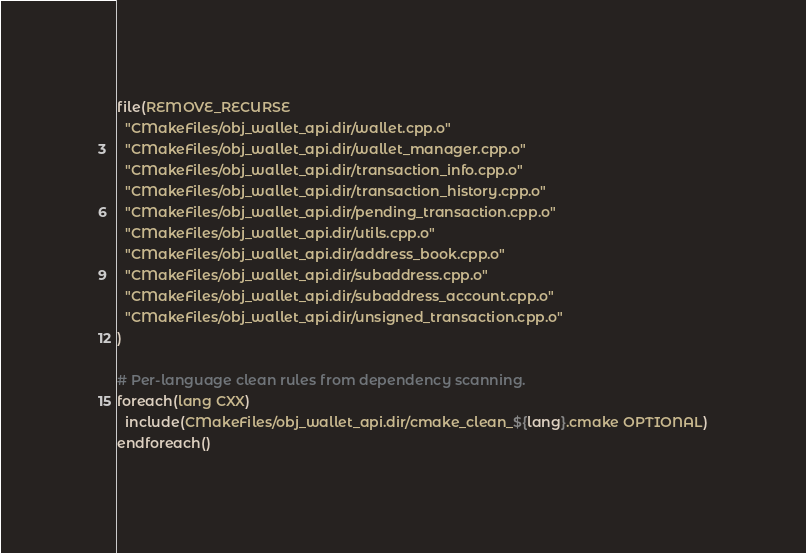Convert code to text. <code><loc_0><loc_0><loc_500><loc_500><_CMake_>file(REMOVE_RECURSE
  "CMakeFiles/obj_wallet_api.dir/wallet.cpp.o"
  "CMakeFiles/obj_wallet_api.dir/wallet_manager.cpp.o"
  "CMakeFiles/obj_wallet_api.dir/transaction_info.cpp.o"
  "CMakeFiles/obj_wallet_api.dir/transaction_history.cpp.o"
  "CMakeFiles/obj_wallet_api.dir/pending_transaction.cpp.o"
  "CMakeFiles/obj_wallet_api.dir/utils.cpp.o"
  "CMakeFiles/obj_wallet_api.dir/address_book.cpp.o"
  "CMakeFiles/obj_wallet_api.dir/subaddress.cpp.o"
  "CMakeFiles/obj_wallet_api.dir/subaddress_account.cpp.o"
  "CMakeFiles/obj_wallet_api.dir/unsigned_transaction.cpp.o"
)

# Per-language clean rules from dependency scanning.
foreach(lang CXX)
  include(CMakeFiles/obj_wallet_api.dir/cmake_clean_${lang}.cmake OPTIONAL)
endforeach()
</code> 